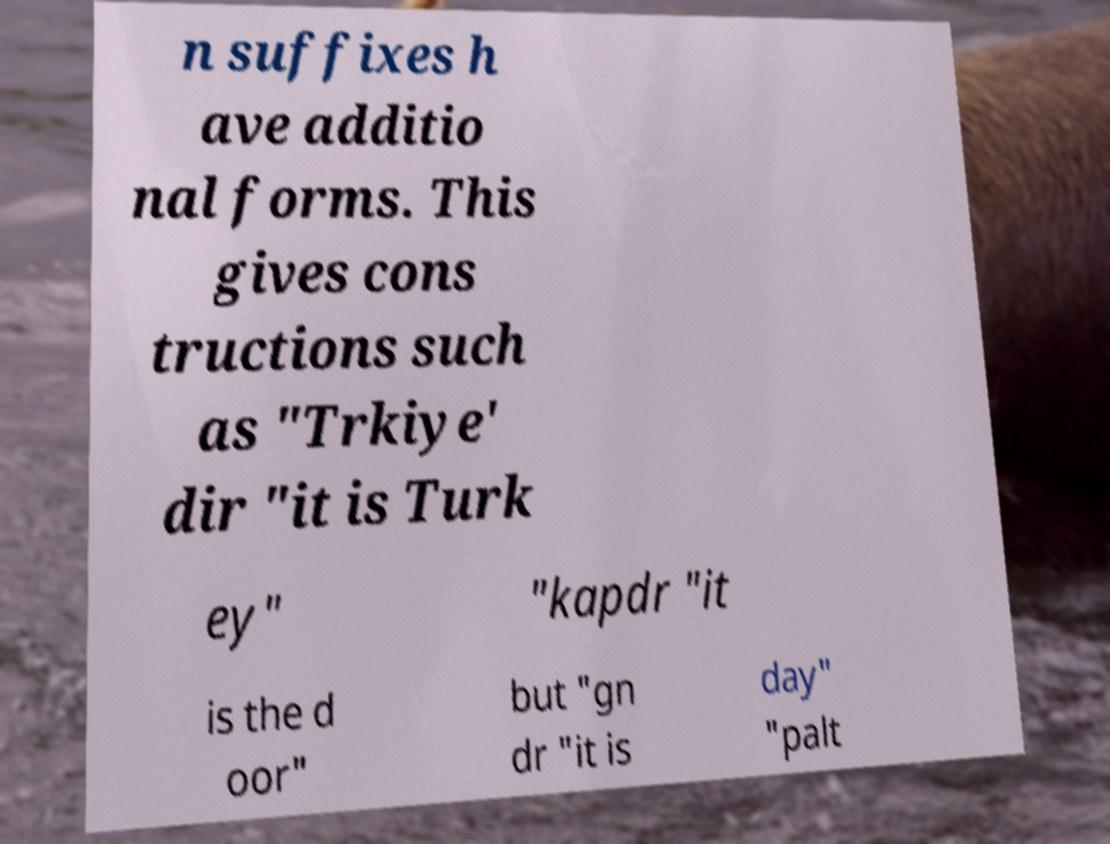There's text embedded in this image that I need extracted. Can you transcribe it verbatim? n suffixes h ave additio nal forms. This gives cons tructions such as "Trkiye' dir "it is Turk ey" "kapdr "it is the d oor" but "gn dr "it is day" "palt 